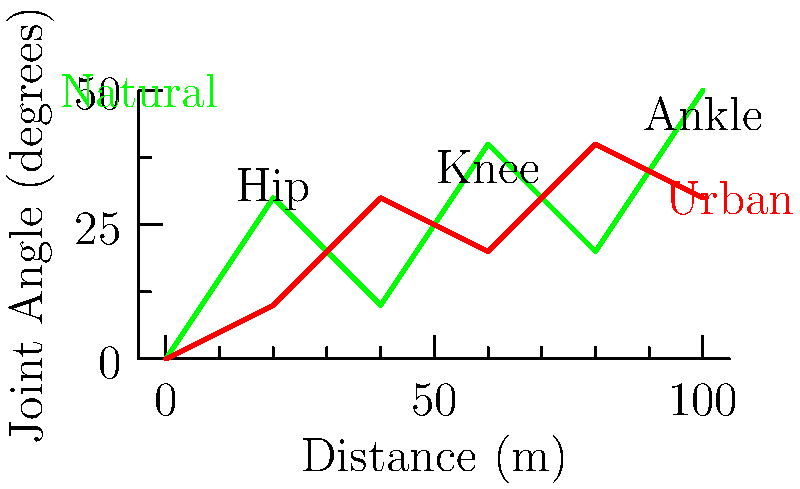Based on the graph comparing joint angles during walking in natural and urban environments, which statement best reflects the potential impact on inner peace and connection to one's surroundings? To answer this question, we need to analyze the graph and consider its implications for inner peace and environmental connection:

1. The graph shows joint angles (hip, knee, and ankle) during walking in natural (green) and urban (red) environments.

2. Natural environment line:
   - Shows more variation in joint angles
   - Has higher peaks and lower troughs
   - Indicates a more dynamic walking pattern

3. Urban environment line:
   - Shows less variation in joint angles
   - Has a more consistent, flatter pattern
   - Indicates a more uniform walking pattern

4. Implications for biomechanics:
   - Natural environments require more diverse joint movements
   - Urban environments lead to more repetitive, less varied movements

5. Connection to inner peace and surroundings:
   - Natural environments:
     a) Require more bodily awareness and engagement
     b) Provide varied sensory input
     c) May promote mindfulness through diverse movements
   - Urban environments:
     a) Allow for more predictable movements
     b) May lead to less conscious engagement with surroundings
     c) Could potentially disconnect one from the body's natural rhythms

6. Philosophical interpretation:
   - The varied movements in natural environments may facilitate a deeper connection to one's body and surroundings, potentially enhancing inner peace through mindful engagement.
   - The uniformity of urban walking may lead to a sense of disconnection from one's body and environment, potentially hindering the achievement of inner peace.

Therefore, the statement that best reflects the potential impact on inner peace and connection to one's surroundings would emphasize the role of varied movements and environmental engagement in promoting mindfulness and bodily awareness.
Answer: Natural environments promote varied movements, potentially enhancing mindfulness and bodily awareness, which may contribute to inner peace and environmental connection. 